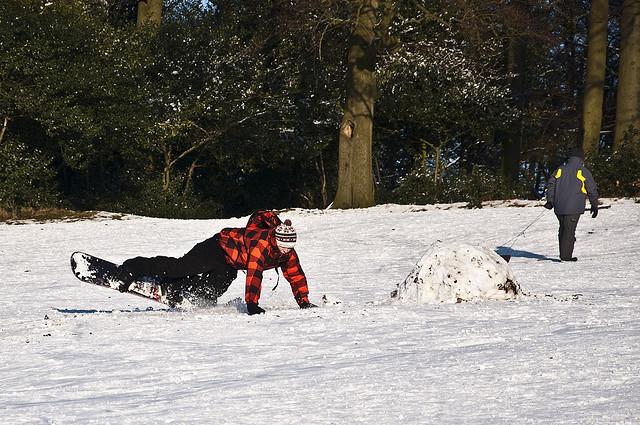How many mounds of snow are there?
Concise answer only. 1. What sport is this?
Concise answer only. Snowboarding. Are there leaves on the trees?
Be succinct. Yes. What is the man dragging?
Quick response, please. Sled. 